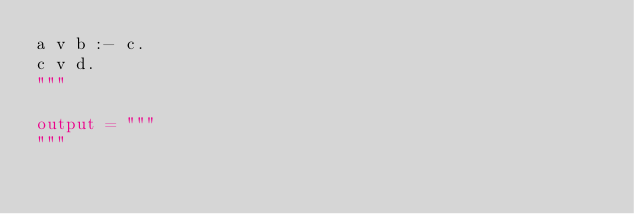<code> <loc_0><loc_0><loc_500><loc_500><_Python_>a v b :- c.
c v d.
"""

output = """
"""
</code> 